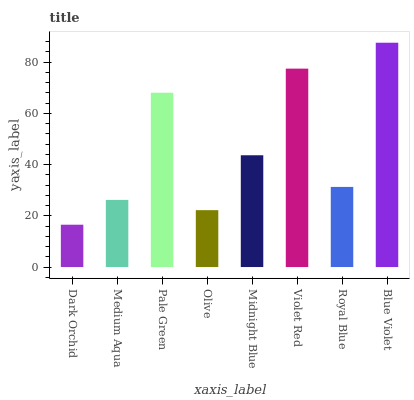Is Dark Orchid the minimum?
Answer yes or no. Yes. Is Blue Violet the maximum?
Answer yes or no. Yes. Is Medium Aqua the minimum?
Answer yes or no. No. Is Medium Aqua the maximum?
Answer yes or no. No. Is Medium Aqua greater than Dark Orchid?
Answer yes or no. Yes. Is Dark Orchid less than Medium Aqua?
Answer yes or no. Yes. Is Dark Orchid greater than Medium Aqua?
Answer yes or no. No. Is Medium Aqua less than Dark Orchid?
Answer yes or no. No. Is Midnight Blue the high median?
Answer yes or no. Yes. Is Royal Blue the low median?
Answer yes or no. Yes. Is Olive the high median?
Answer yes or no. No. Is Violet Red the low median?
Answer yes or no. No. 